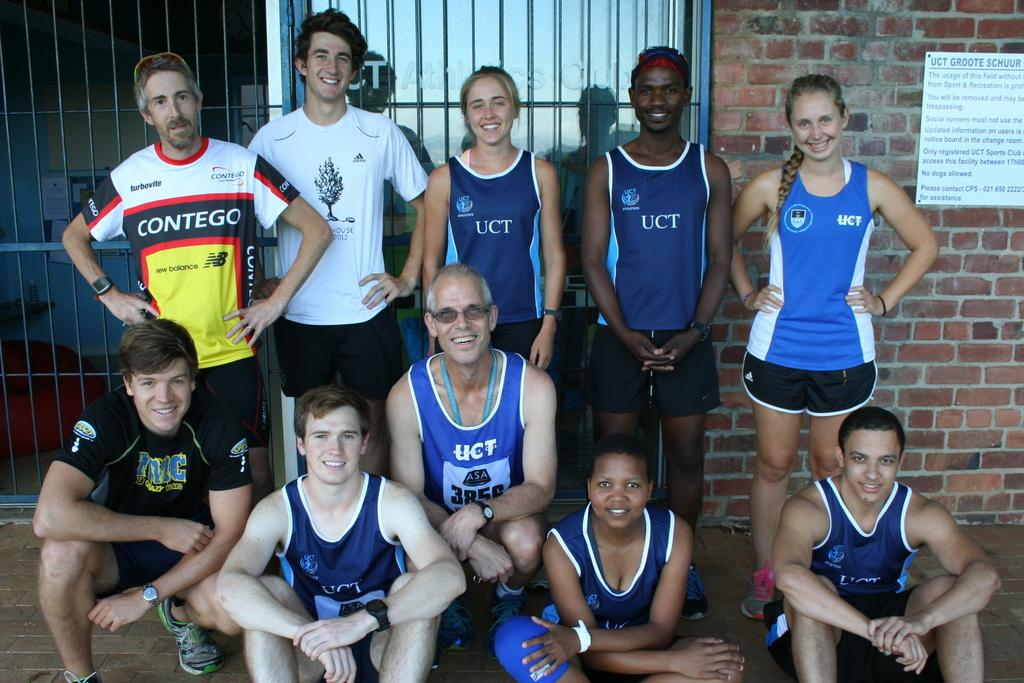<image>
Present a compact description of the photo's key features. UCT team mates posing for a snapshot in their tanktops 